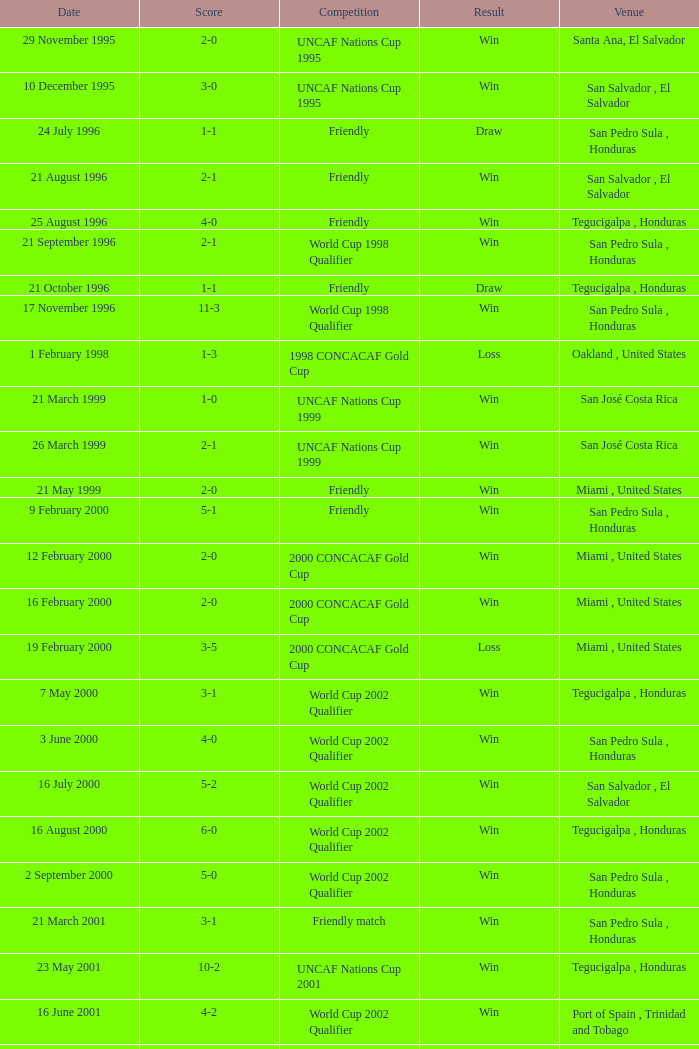What is the venue for the friendly competition and score of 4-0? Tegucigalpa , Honduras. 